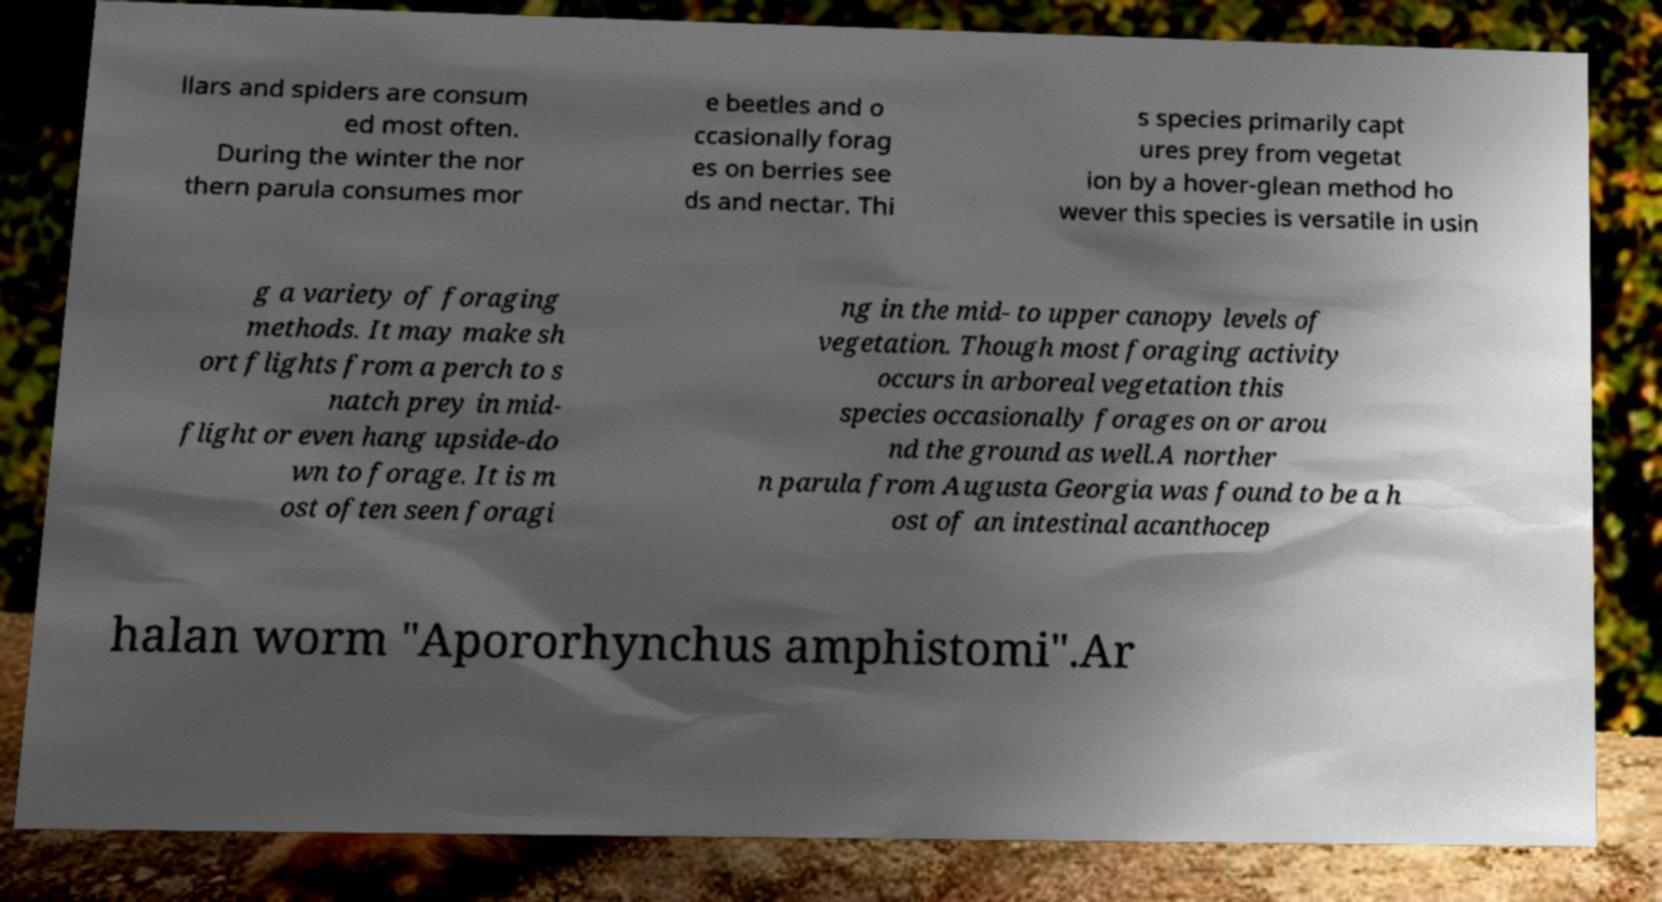Could you extract and type out the text from this image? llars and spiders are consum ed most often. During the winter the nor thern parula consumes mor e beetles and o ccasionally forag es on berries see ds and nectar. Thi s species primarily capt ures prey from vegetat ion by a hover-glean method ho wever this species is versatile in usin g a variety of foraging methods. It may make sh ort flights from a perch to s natch prey in mid- flight or even hang upside-do wn to forage. It is m ost often seen foragi ng in the mid- to upper canopy levels of vegetation. Though most foraging activity occurs in arboreal vegetation this species occasionally forages on or arou nd the ground as well.A norther n parula from Augusta Georgia was found to be a h ost of an intestinal acanthocep halan worm "Apororhynchus amphistomi".Ar 